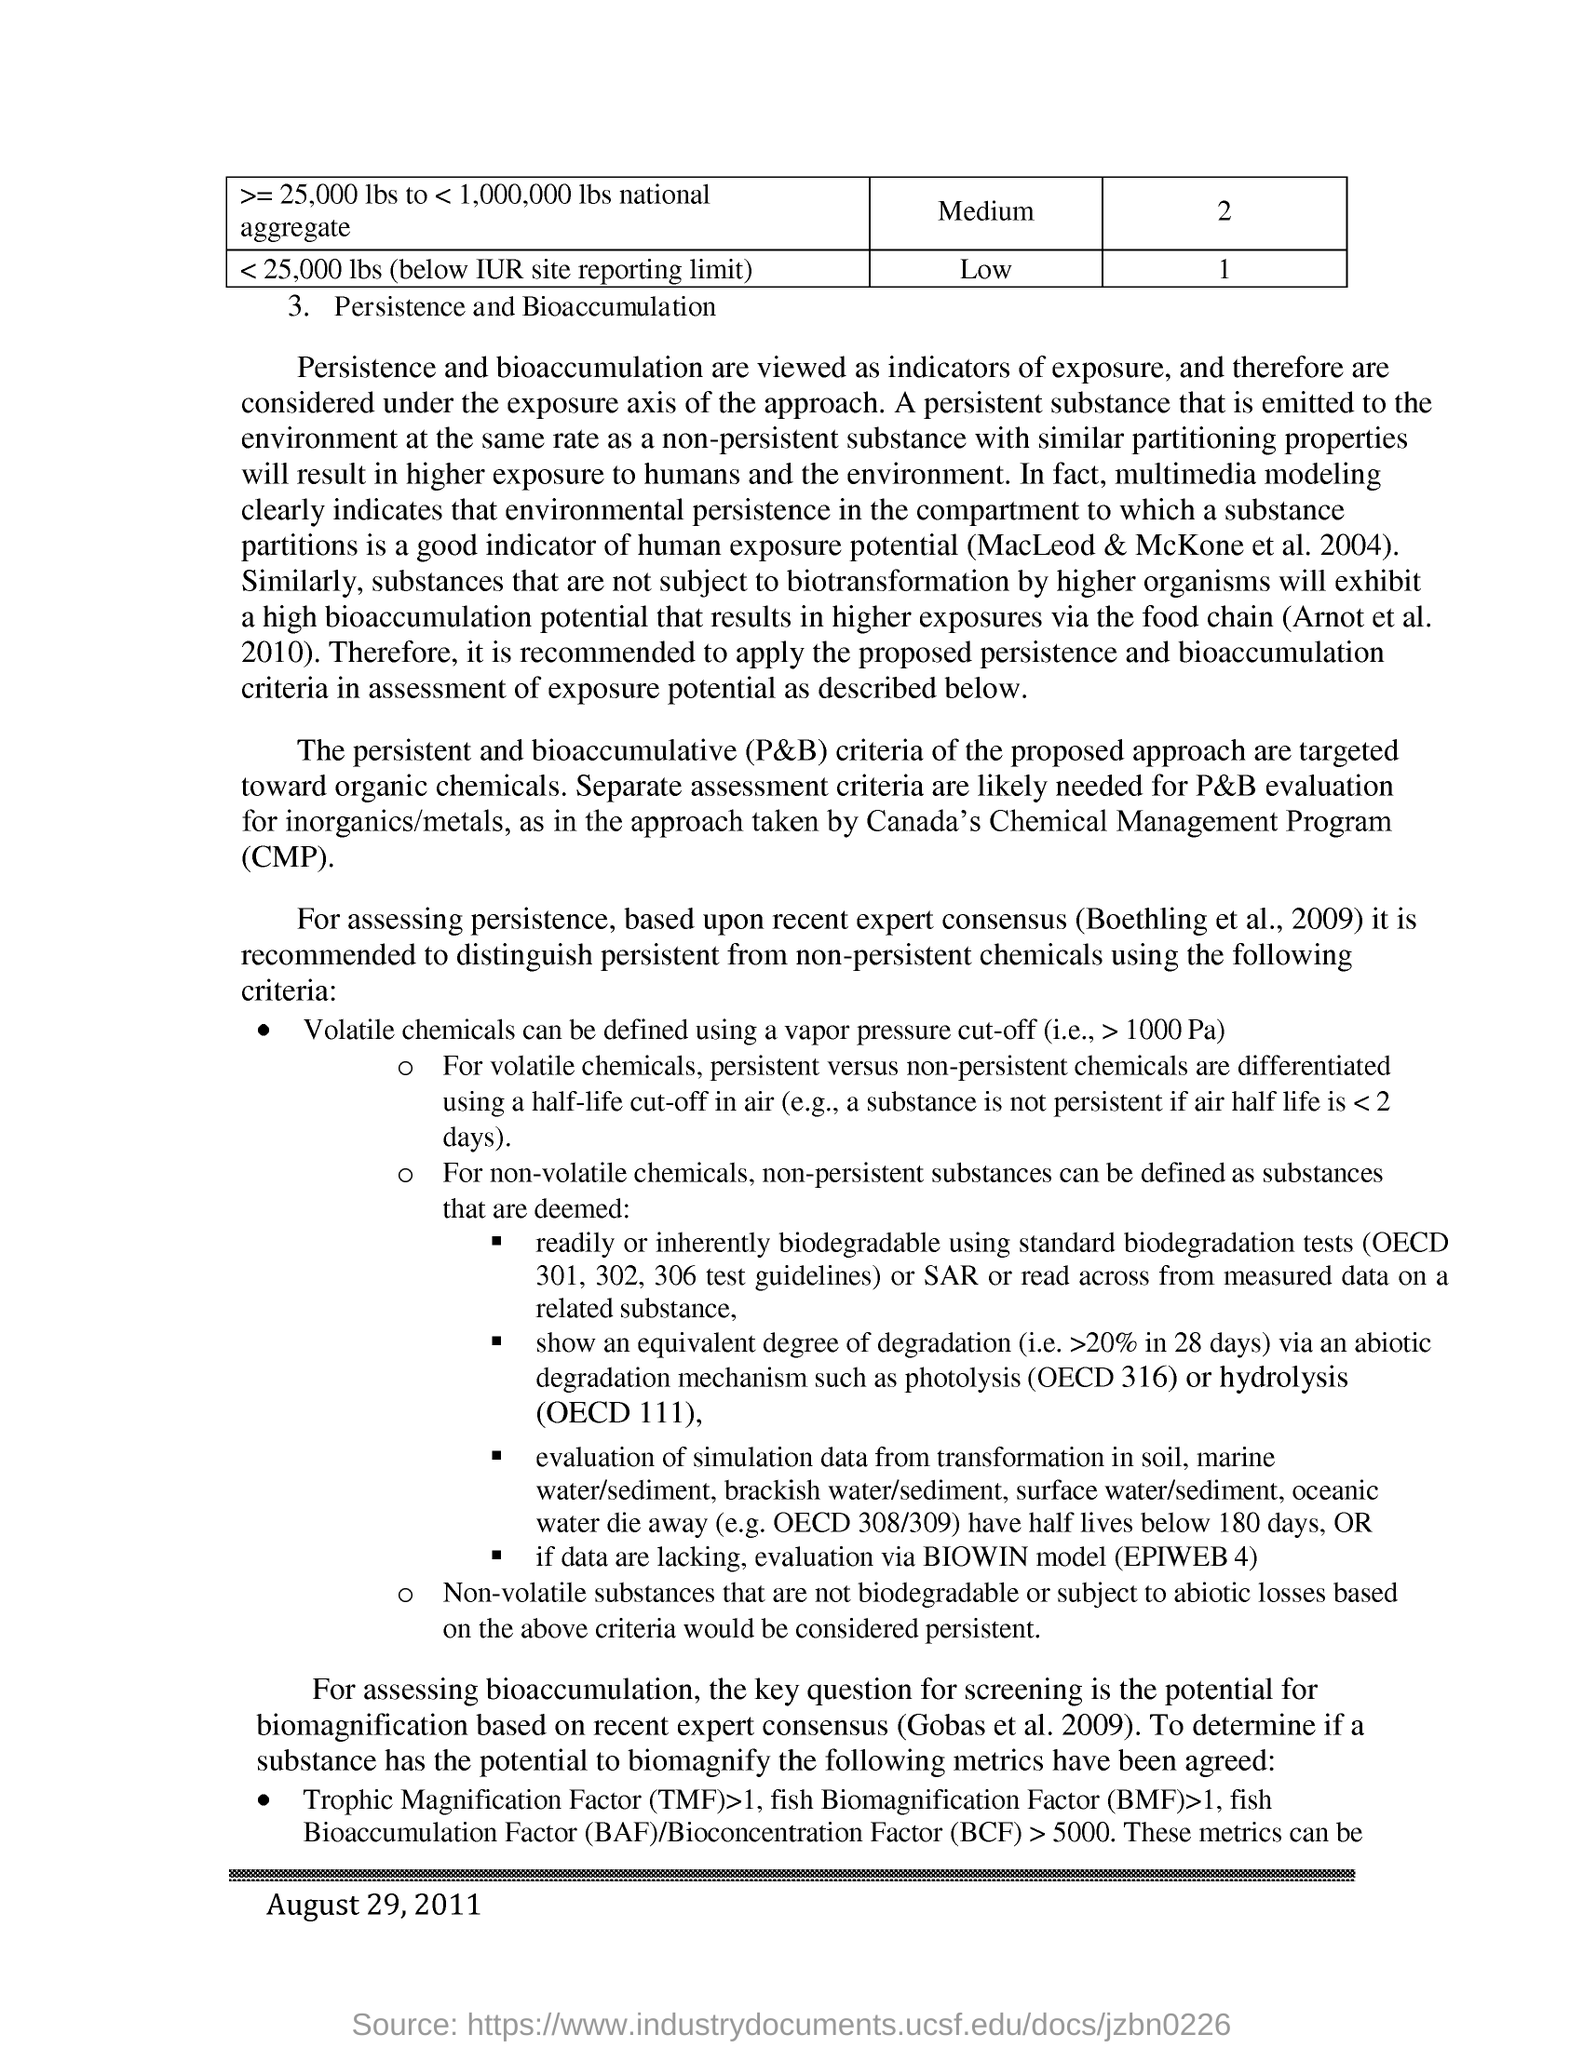Which are viewed as the indicators of exposure?
Offer a very short reply. Persistence and bioaccumulation. What does cmp stands for?
Give a very brief answer. Chemical management program. P&B criteria of the proposed approach are targeted towards?
Your answer should be very brief. Organic chemicals. Which can be defined using a vapour presure cut-off ?
Provide a succinct answer. Volatile chemicals. What does tmf stands for?
Your response must be concise. Trophic magnification factor. 